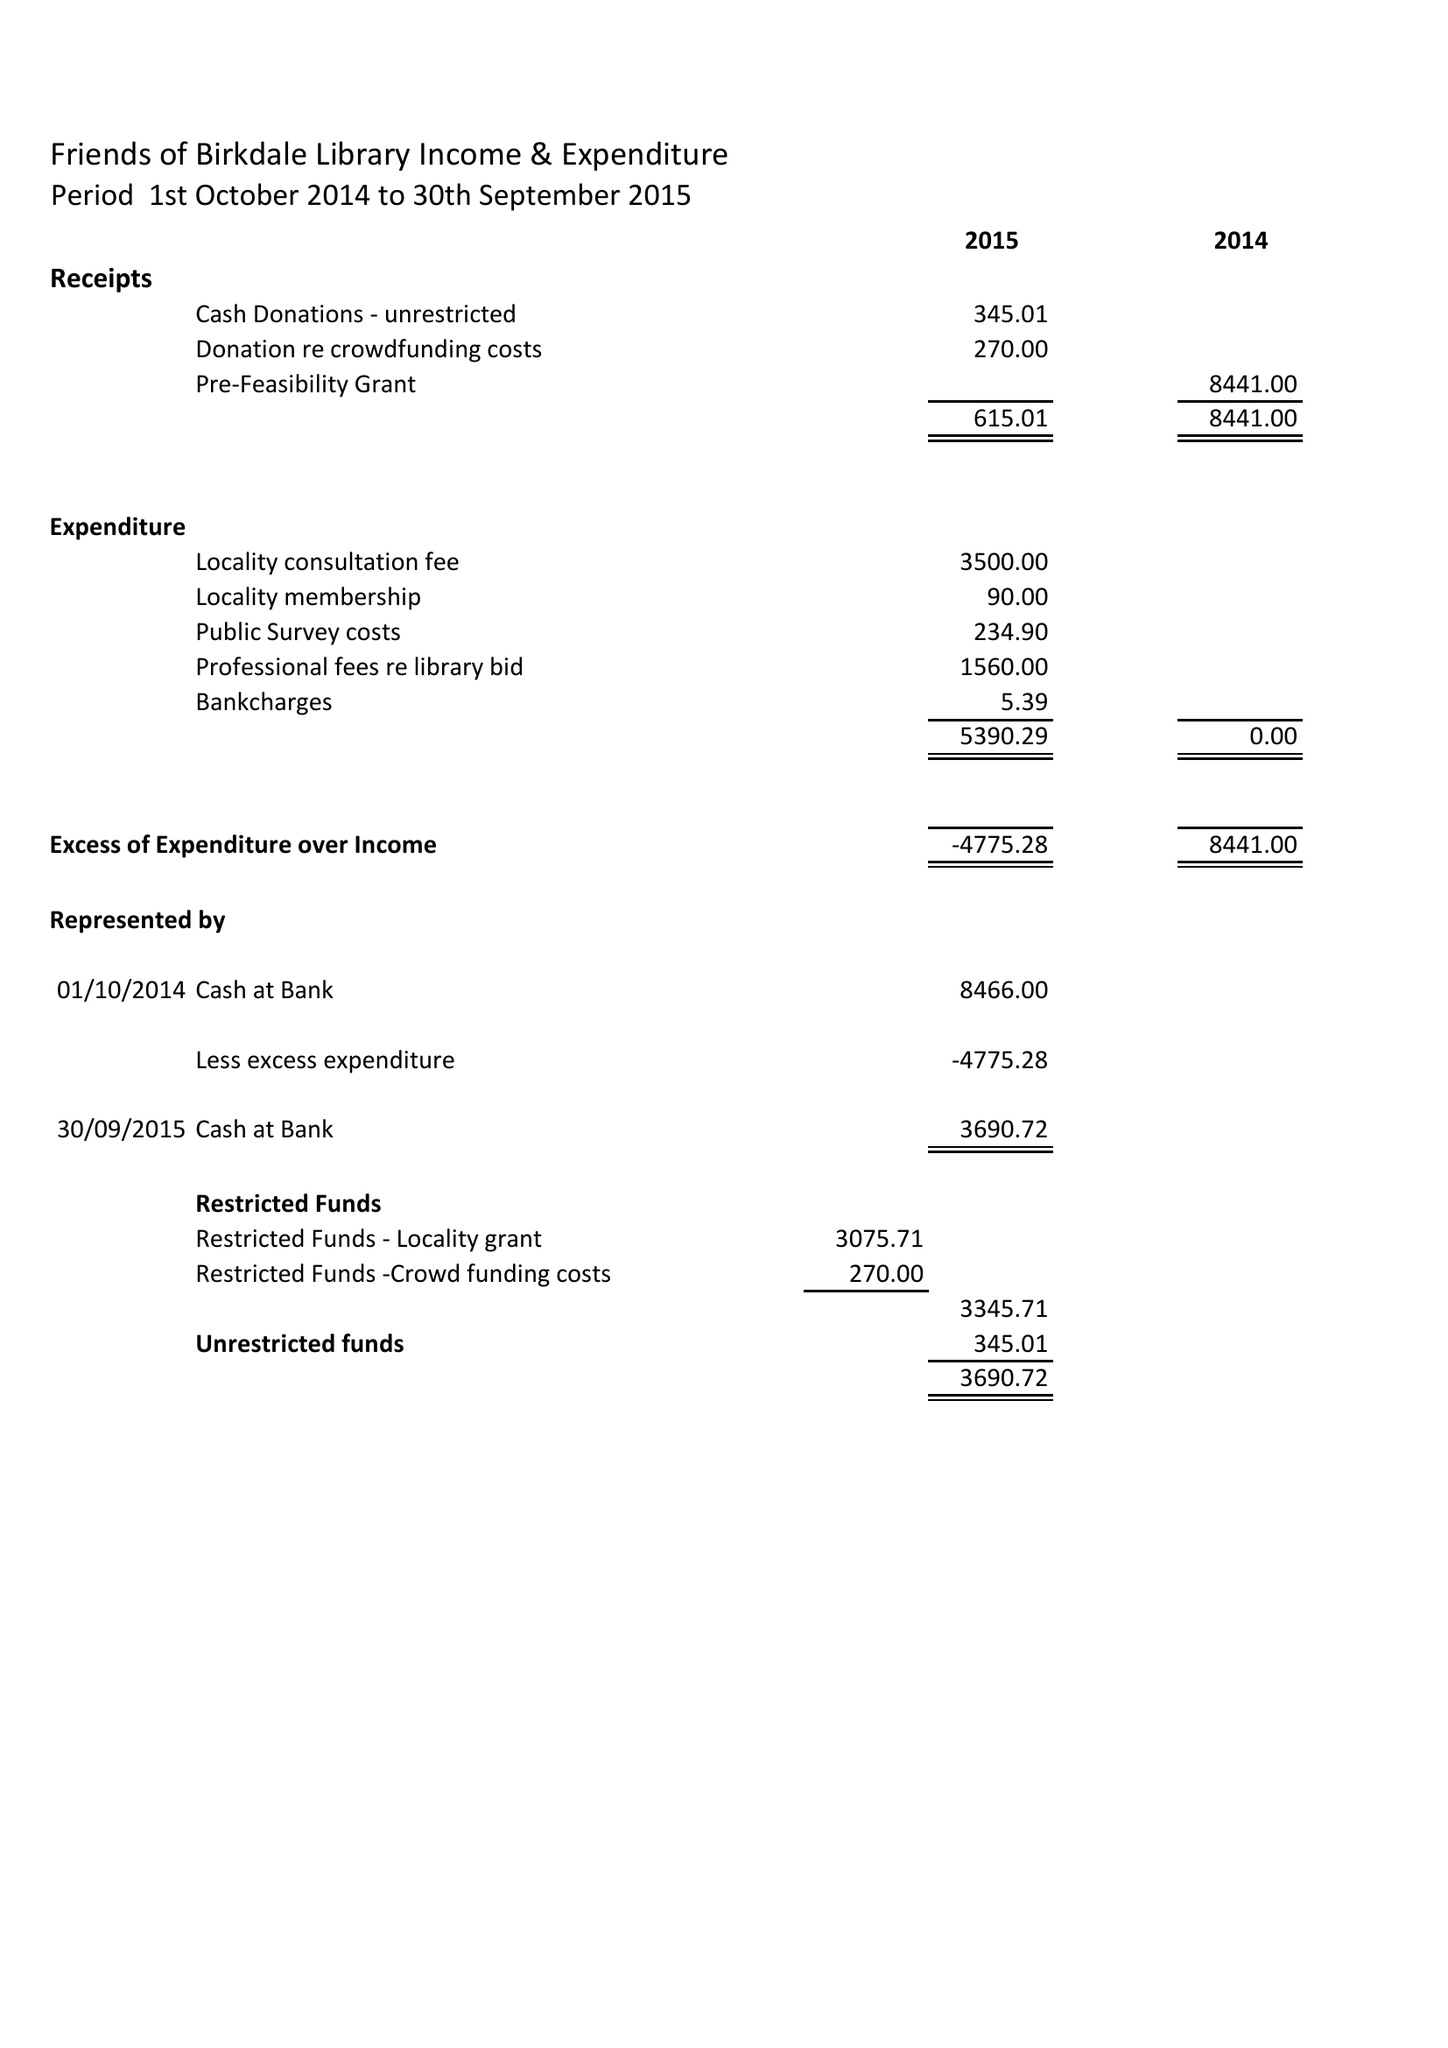What is the value for the address__postcode?
Answer the question using a single word or phrase. PR8 3QS 